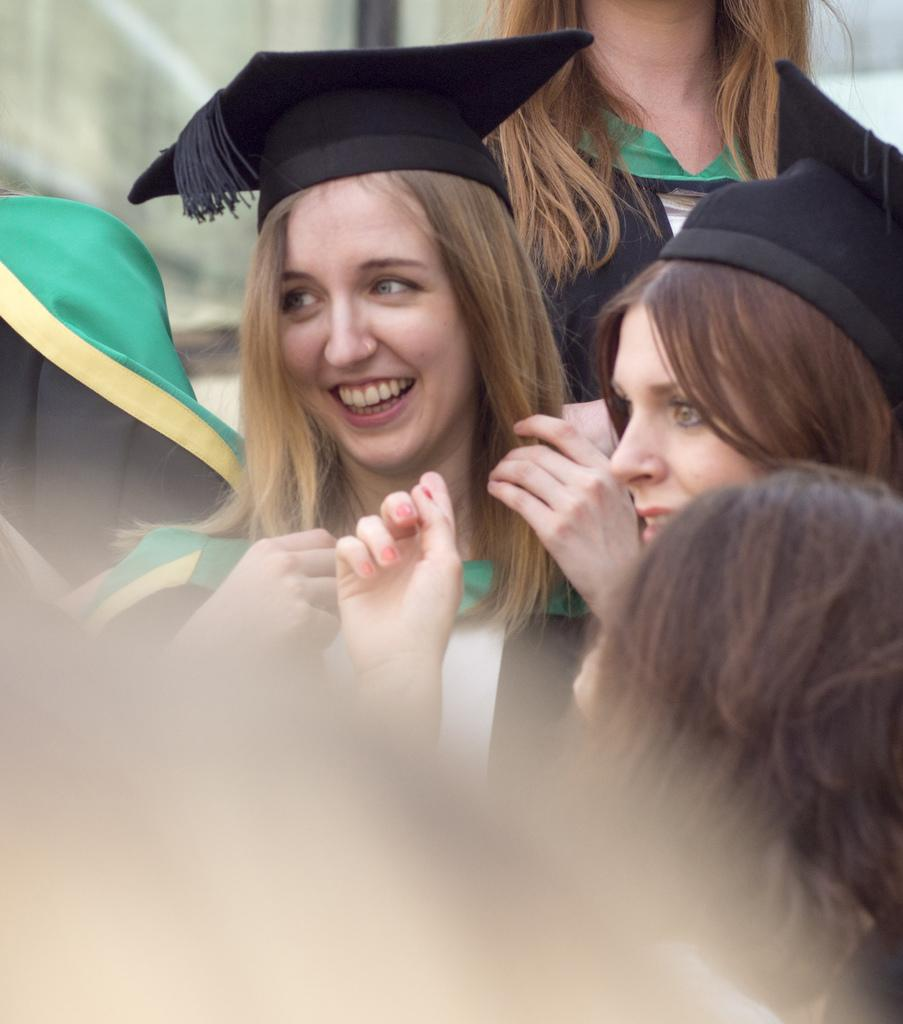How many people are in the image? There are people in the image, but the exact number is not specified. What are two of the people wearing? Two of the people are wearing hats. Can you describe the background of the image? The background of the image is blurry. What type of bait is being used by the people in the image? There is no mention of fishing or bait in the image, so it cannot be determined. 